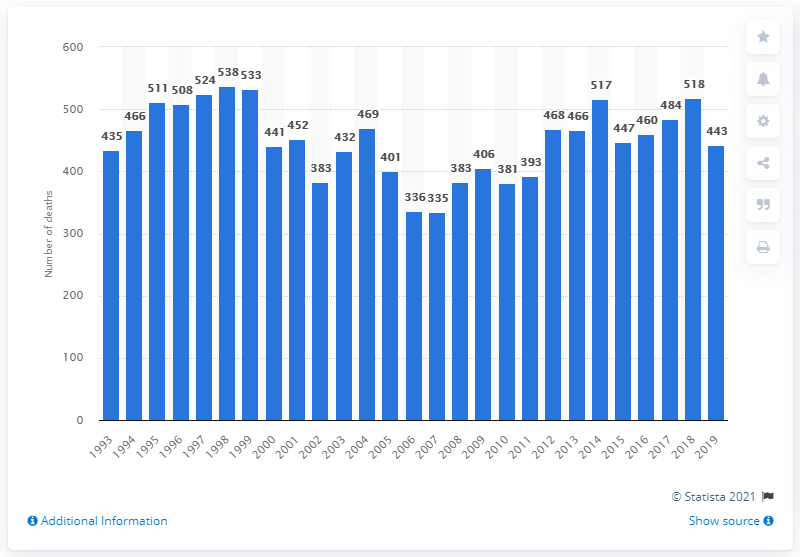Give some essential details in this illustration. In 1998, a total of 538 deaths were caused by antidepressants. It is reported that the largest number of deaths caused by antidepressants was recorded in 1998. In 2019, a total of 443 deaths were caused by antidepressants. 